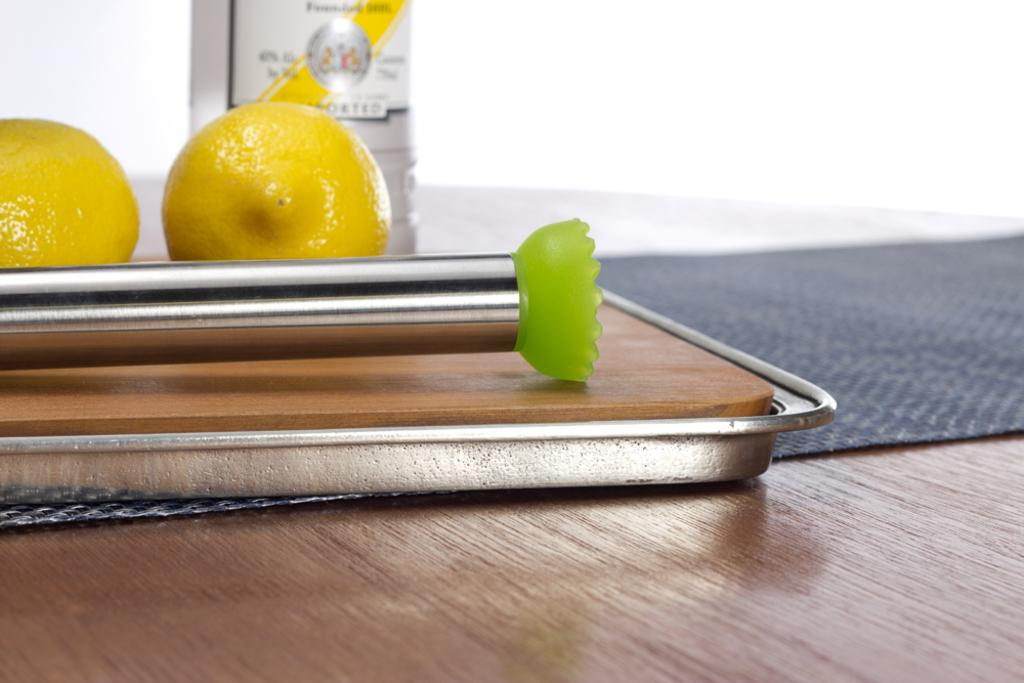What is the main object on the table in the image? There is a wooden board on the table in the image. What is in front of the wooden board? There is a pole in front of the wooden board. What can be seen on the pole? There are two yellow color fruits on the pole. What is the color of the table? The table is in brown color. What type of thrill can be experienced by playing volleyball on the wooden board in the image? There is no volleyball or any indication of a game being played in the image. The wooden board is simply an object on the table. 